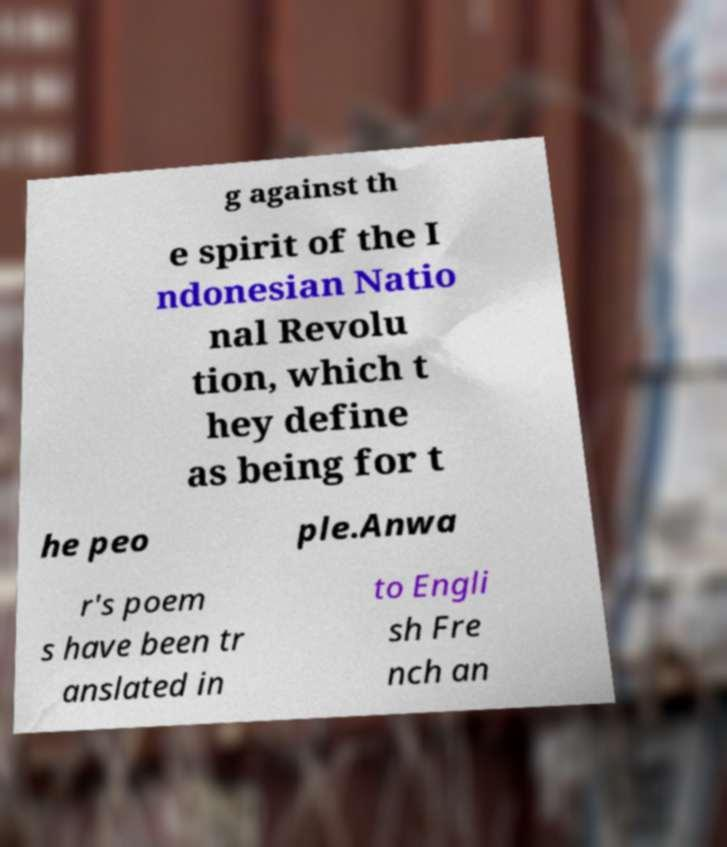Could you extract and type out the text from this image? g against th e spirit of the I ndonesian Natio nal Revolu tion, which t hey define as being for t he peo ple.Anwa r's poem s have been tr anslated in to Engli sh Fre nch an 